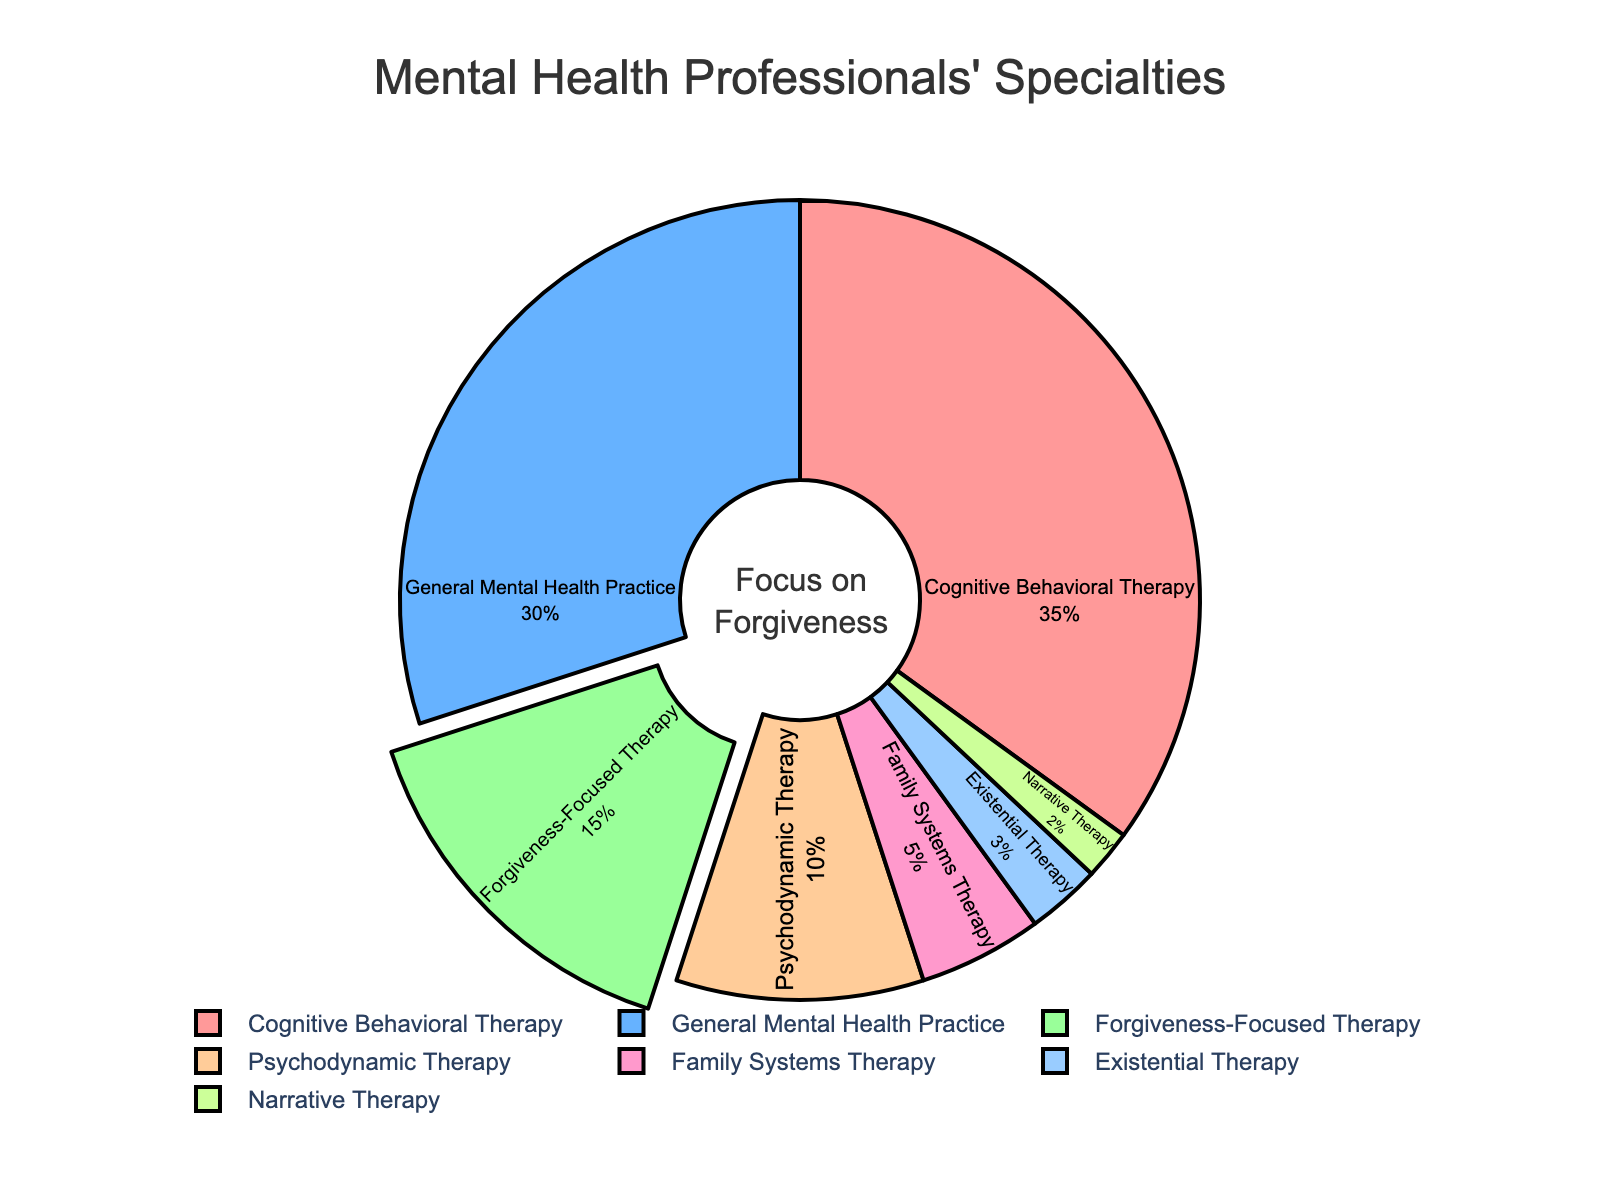What proportion of mental health professionals specialize in therapies other than forgiveness-focused therapy? To find this, subtract the proportion of forgiveness-focused therapy from the total (100%). The proportion of forgiveness-focused therapy is 15%, so other therapies make up 100% - 15% = 85%
Answer: 85% Which specialty has the largest percentage of mental health professionals, and what is that percentage? Look at the pie chart segment with the largest area, which has the label "Cognitive Behavioral Therapy" and the text showing it covers 35%
Answer: Cognitive Behavioral Therapy, 35% How do the percentages of Cognitive Behavioral Therapy and General Mental Health Practice compare? The pie chart shows Cognitive Behavioral Therapy (35%) and General Mental Health Practice (30%). Comparing them, Cognitive Behavioral Therapy has a 5% higher share
Answer: Cognitive Behavioral Therapy has a 5% higher share What is the combined percentage of mental health professionals specializing in Psychodynamic Therapy and Family Systems Therapy? According to the chart, Psychodynamic Therapy accounts for 10% and Family Systems Therapy for 5%. Their combination is 10% + 5% = 15%
Answer: 15% Which specialty occupies the smallest segment in the pie chart? The smallest section corresponds to Narrative Therapy, which occupies 2% according to the chart labels
Answer: Narrative Therapy, 2% What is the percentage difference between Existential Therapy and Narrative Therapy? Existential Therapy is 3% while Narrative Therapy is 2%, so the difference is 3% - 2% = 1%
Answer: 1% What does the annotation "Focus on Forgiveness" inside the pie chart represent, and why is it there? The annotation highlights the portion of the pie chart representing "Forgiveness-Focused Therapy," which is specifically highlighted to draw attention to this specialty's proportion, given the pie pull-out feature
Answer: It highlights Forgiveness-Focused Therapy Which has a greater percentage, Forgiveness-Focused Therapy or Psychodynamic Therapy and by how much? Forgiveness-Focused Therapy has 15%, and Psychodynamic Therapy has 10%. The difference is 15% - 10% = 5%
Answer: Forgiveness-Focused Therapy by 5% 